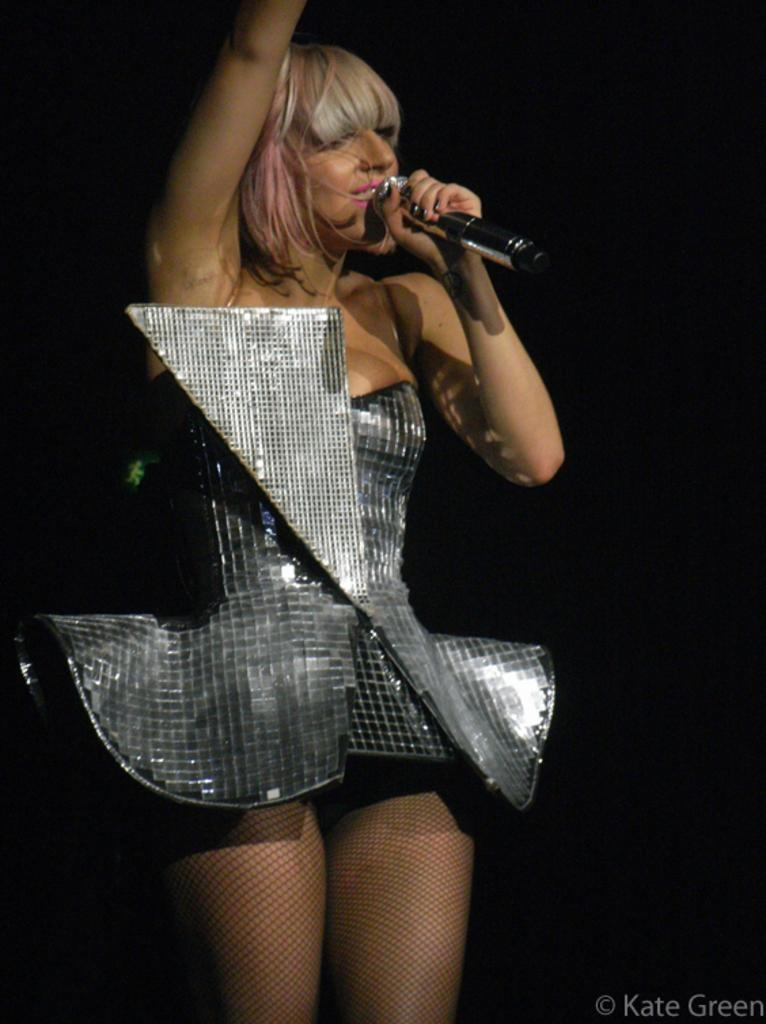Who is the main subject in the image? There is a woman in the image. What is the woman wearing? The woman is wearing a costume. What is the woman doing in the image? The woman is singing a song. What object is the woman holding in her hand? The woman is holding a microphone in her hand. Where is the woman eating her lunch in the image? There is no lunch or lunchroom present in the image; the woman is singing a song while holding a microphone. 